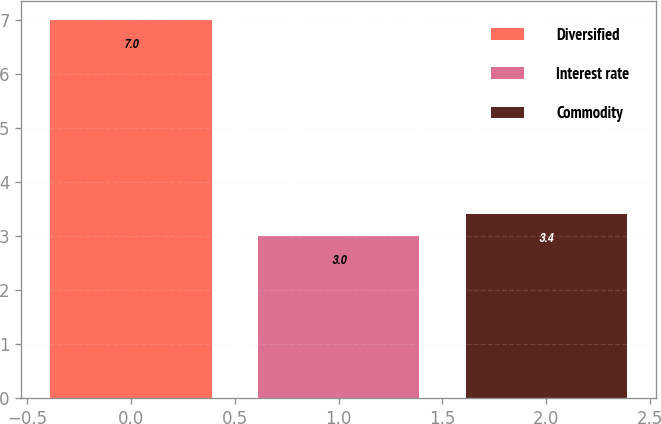Convert chart. <chart><loc_0><loc_0><loc_500><loc_500><bar_chart><fcel>Diversified<fcel>Interest rate<fcel>Commodity<nl><fcel>7<fcel>3<fcel>3.4<nl></chart> 